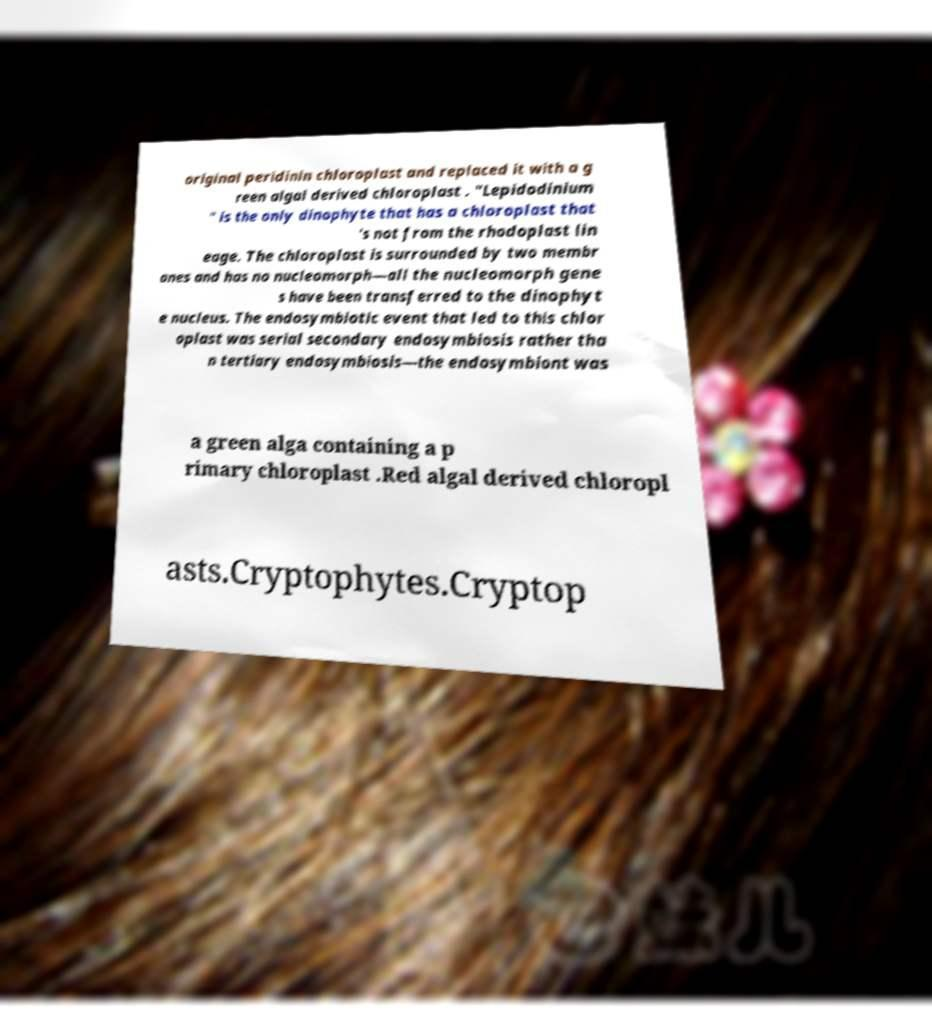Please identify and transcribe the text found in this image. original peridinin chloroplast and replaced it with a g reen algal derived chloroplast . "Lepidodinium " is the only dinophyte that has a chloroplast that 's not from the rhodoplast lin eage. The chloroplast is surrounded by two membr anes and has no nucleomorph—all the nucleomorph gene s have been transferred to the dinophyt e nucleus. The endosymbiotic event that led to this chlor oplast was serial secondary endosymbiosis rather tha n tertiary endosymbiosis—the endosymbiont was a green alga containing a p rimary chloroplast .Red algal derived chloropl asts.Cryptophytes.Cryptop 